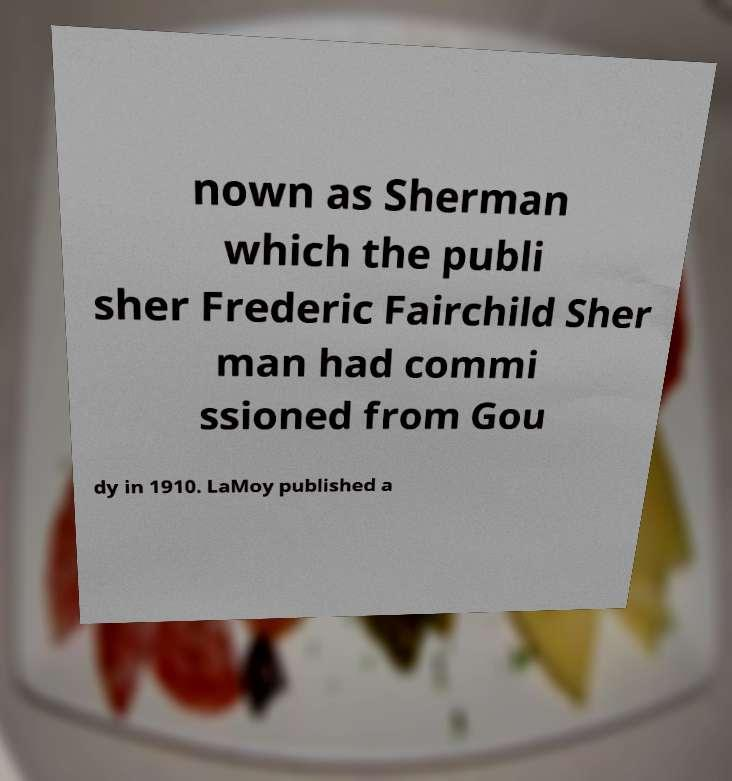Please read and relay the text visible in this image. What does it say? nown as Sherman which the publi sher Frederic Fairchild Sher man had commi ssioned from Gou dy in 1910. LaMoy published a 